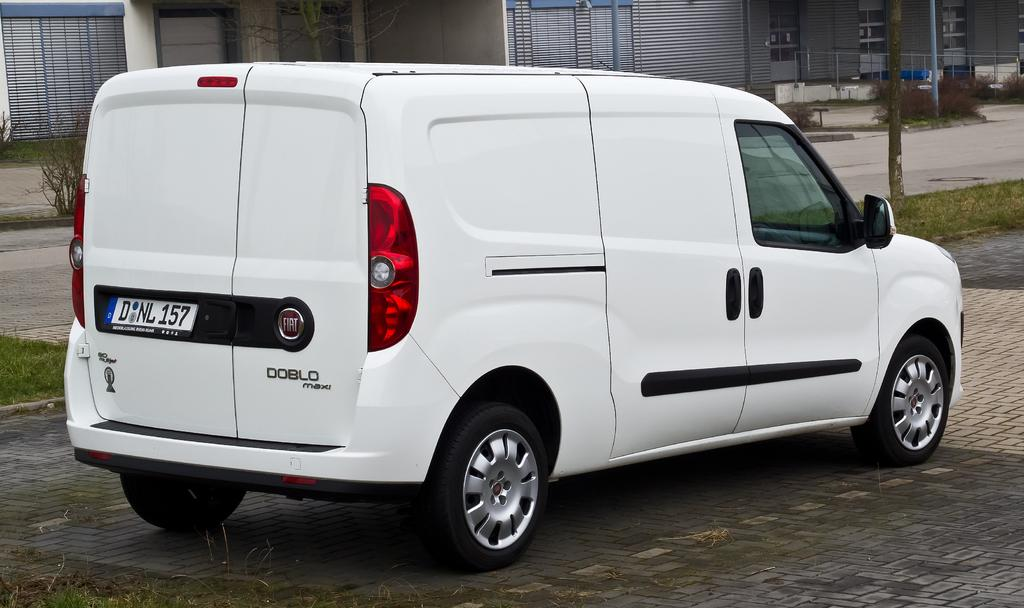Provide a one-sentence caption for the provided image. A white DOBLO maxi on bricks created for the road. 